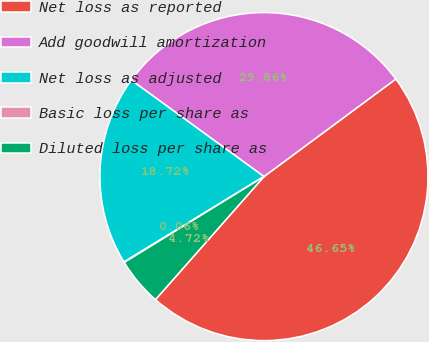Convert chart to OTSL. <chart><loc_0><loc_0><loc_500><loc_500><pie_chart><fcel>Net loss as reported<fcel>Add goodwill amortization<fcel>Net loss as adjusted<fcel>Basic loss per share as<fcel>Diluted loss per share as<nl><fcel>46.65%<fcel>29.86%<fcel>18.72%<fcel>0.06%<fcel>4.72%<nl></chart> 